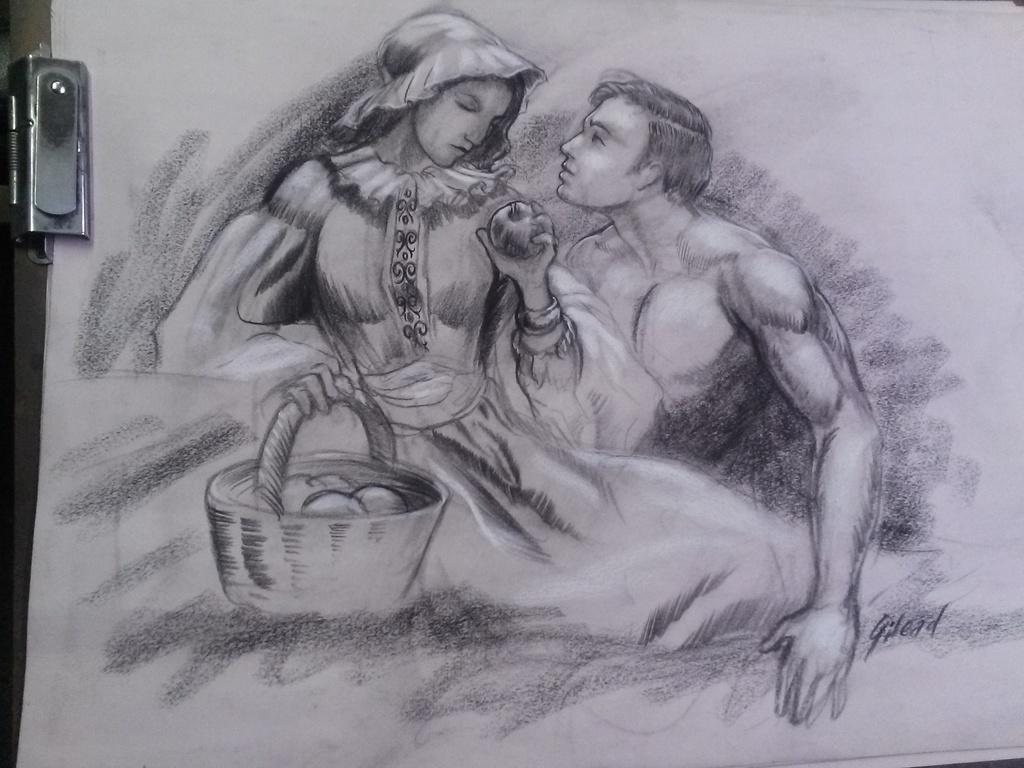How would you summarize this image in a sentence or two? In this image we can see a painting on the paper. In this image we can see two persons, basket and a fruit. On the left side of the image there is an object. 